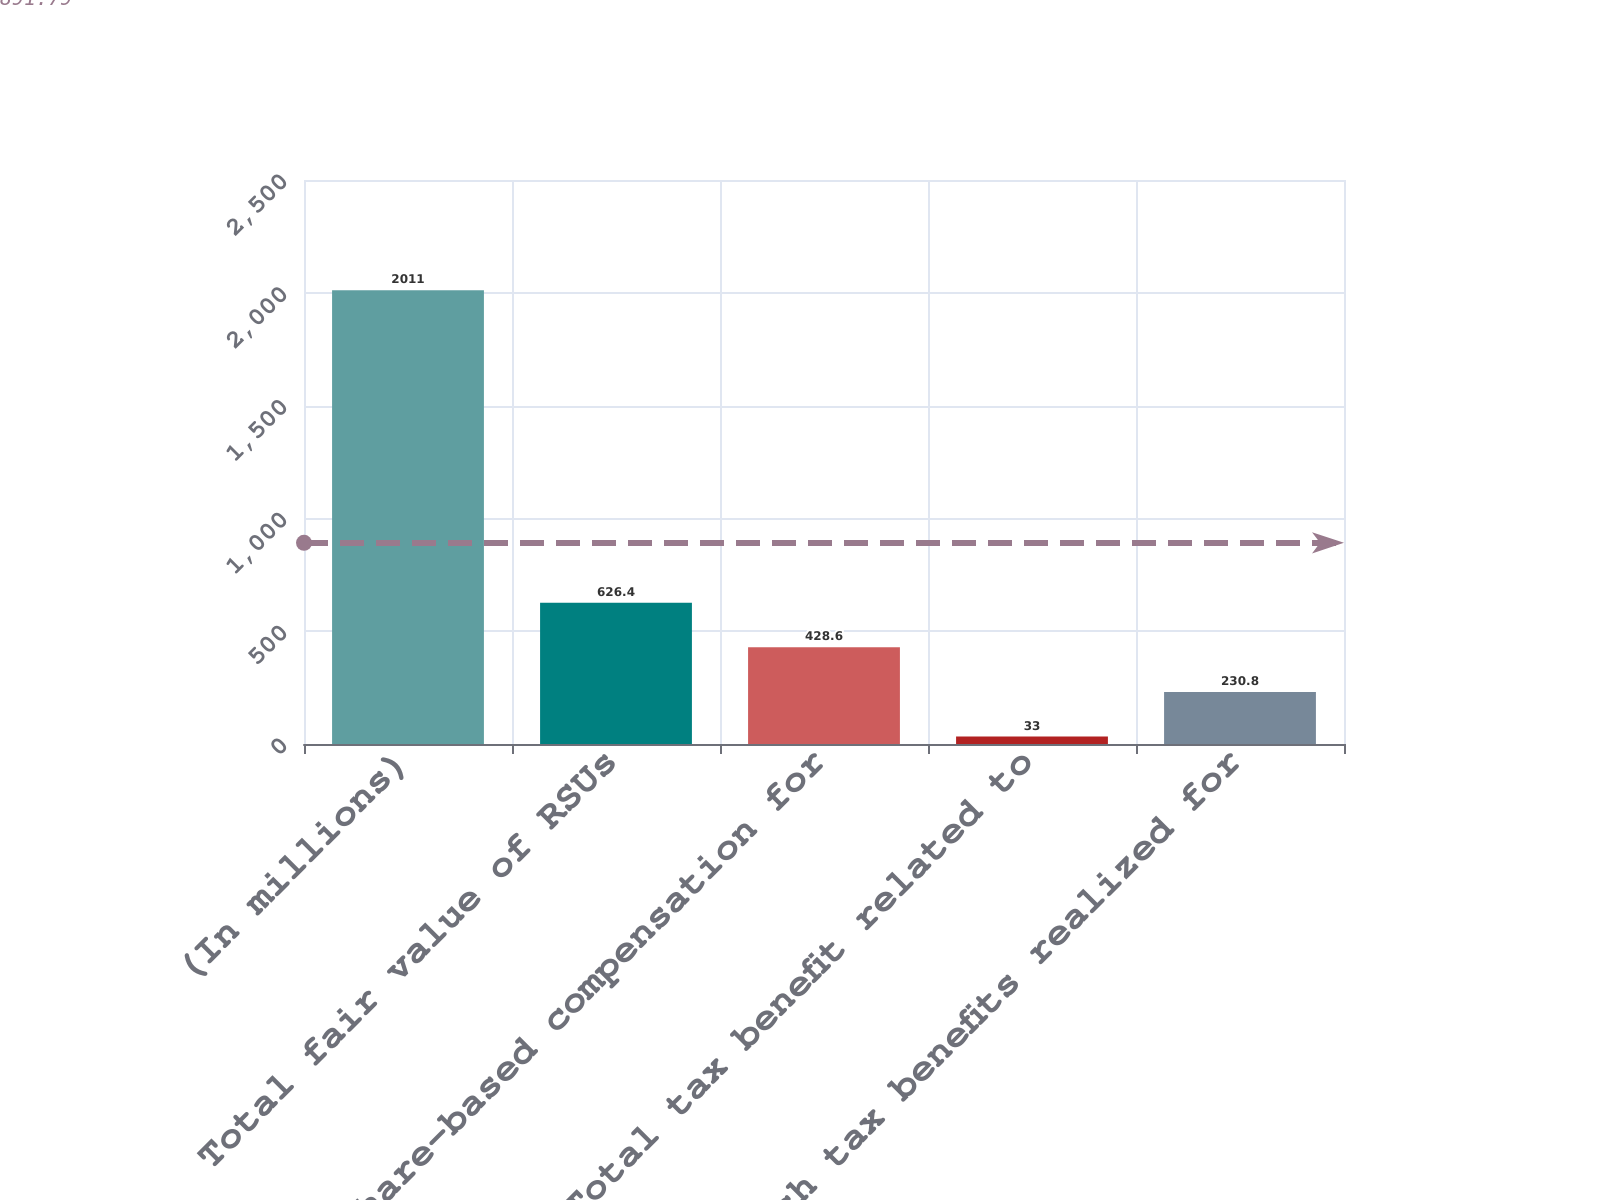<chart> <loc_0><loc_0><loc_500><loc_500><bar_chart><fcel>(In millions)<fcel>Total fair value of RSUs<fcel>Share-based compensation for<fcel>Total tax benefit related to<fcel>Cash tax benefits realized for<nl><fcel>2011<fcel>626.4<fcel>428.6<fcel>33<fcel>230.8<nl></chart> 